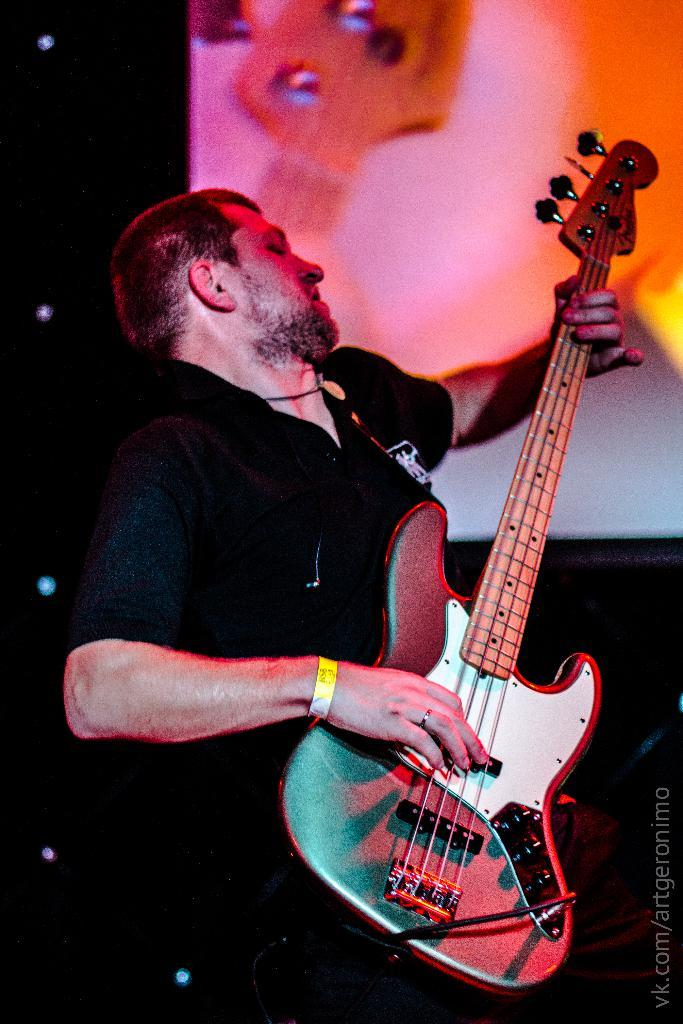Who is the main subject in the image? There is a man in the center of the image. What is the man doing in the image? The man is playing a guitar. What color is the shirt the man is wearing? The man is wearing a black shirt. What can be seen in the background of the image? There is a board in the background of the image. What type of snow can be seen falling in the image? There is no snow present in the image. What government policy is being discussed in the image? There is no discussion of government policy in the image; it features a man playing a guitar. 